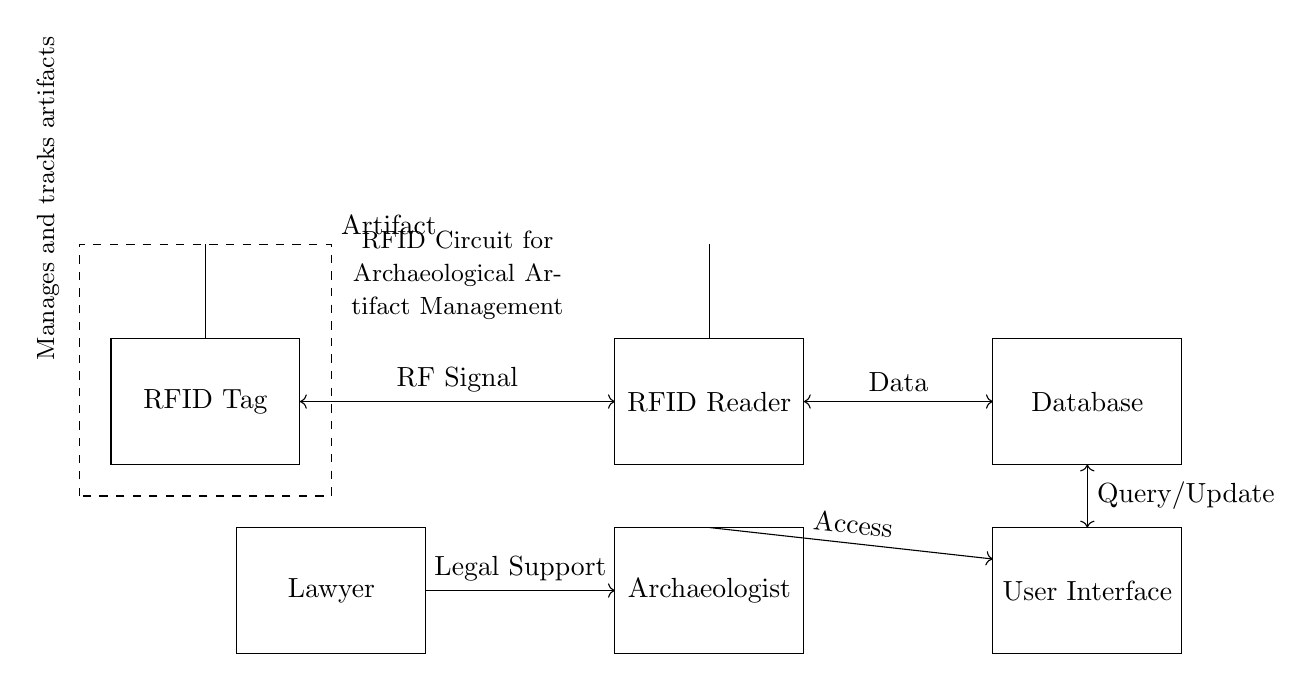What is the primary function of the RFID circuit? The RFID circuit is designed to manage and track archaeological artifacts by using radio frequency identification technology to communicate between the RFID tags on the artifacts and the RFID reader.
Answer: manage and track artifacts Who uses the user interface? The user interface is used by the archaeologist to query and update information related to the tracked artifacts stored in the database.
Answer: archaeologist What type of connection is shown between the RFID tag and the RFID reader? The connection is indicated as an RF signal, which allows the RFID reader to communicate with the RFID tag without physical contact, using radio waves.
Answer: RF Signal What role does the lawyer play in this circuit? The lawyer provides legal support concerning the management and tracking of the archaeological artifacts, ensuring compliance with legal requirements.
Answer: Legal Support How many components are there in the circuit diagram? There are five main components depicted in the circuit: the RFID tag, RFID reader, database, user interface, and the archaeologist, along with the lawyer's role diagrammatically represented.
Answer: five What is the primary type of communication used in this circuit? The primary type of communication utilized in this RFID circuit is through radio frequency signals, allowing efficient non-contact data exchange between components.
Answer: radio frequency signals Where is the database located in the circuit diagram? The database is represented on the far right side of the diagram, adjacent to the RFID reader, indicating that it receives data from the reader after scanning the RFID tag.
Answer: far right side 